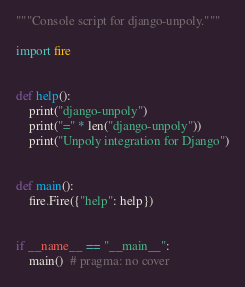Convert code to text. <code><loc_0><loc_0><loc_500><loc_500><_Python_>"""Console script for django-unpoly."""

import fire


def help():
    print("django-unpoly")
    print("=" * len("django-unpoly"))
    print("Unpoly integration for Django")


def main():
    fire.Fire({"help": help})


if __name__ == "__main__":
    main()  # pragma: no cover
</code> 